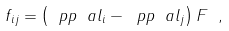<formula> <loc_0><loc_0><loc_500><loc_500>f _ { i j } = \left ( \ p p { \ a l _ { i } } - \ p p { \ a l _ { j } } \right ) F \ ,</formula> 